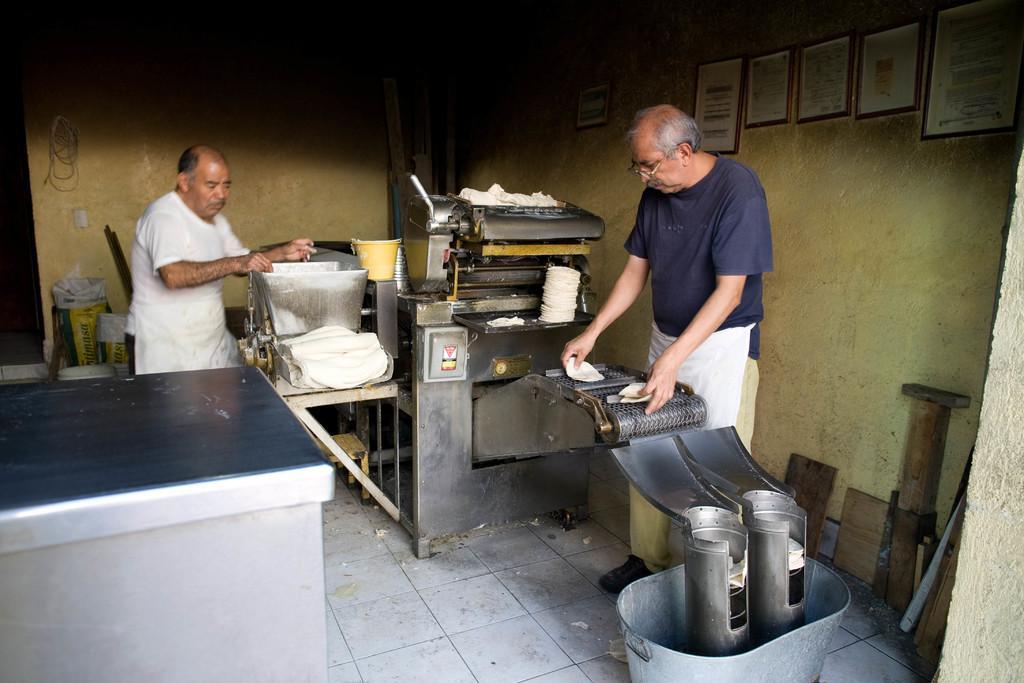Describe this image in one or two sentences. On the left there is a table. on the right it is well. In the middle of the picture we can see two persons, machinery, bucket, food item and various objects. In the background it is wall, to the wall we can see frames, cable. 